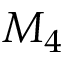<formula> <loc_0><loc_0><loc_500><loc_500>M _ { 4 }</formula> 